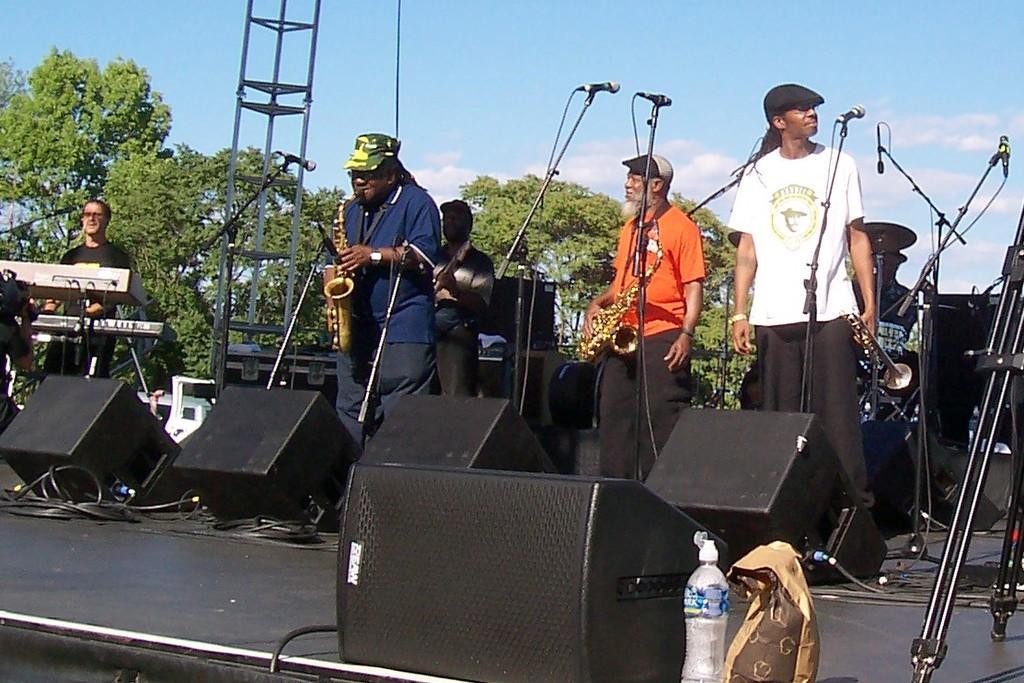Could you give a brief overview of what you see in this image? In the image people are playing musical instruments. There are mic in front of them on the stage there are speaker, bottle,bag. On the background there are trees. In the sky there are some cloud. 